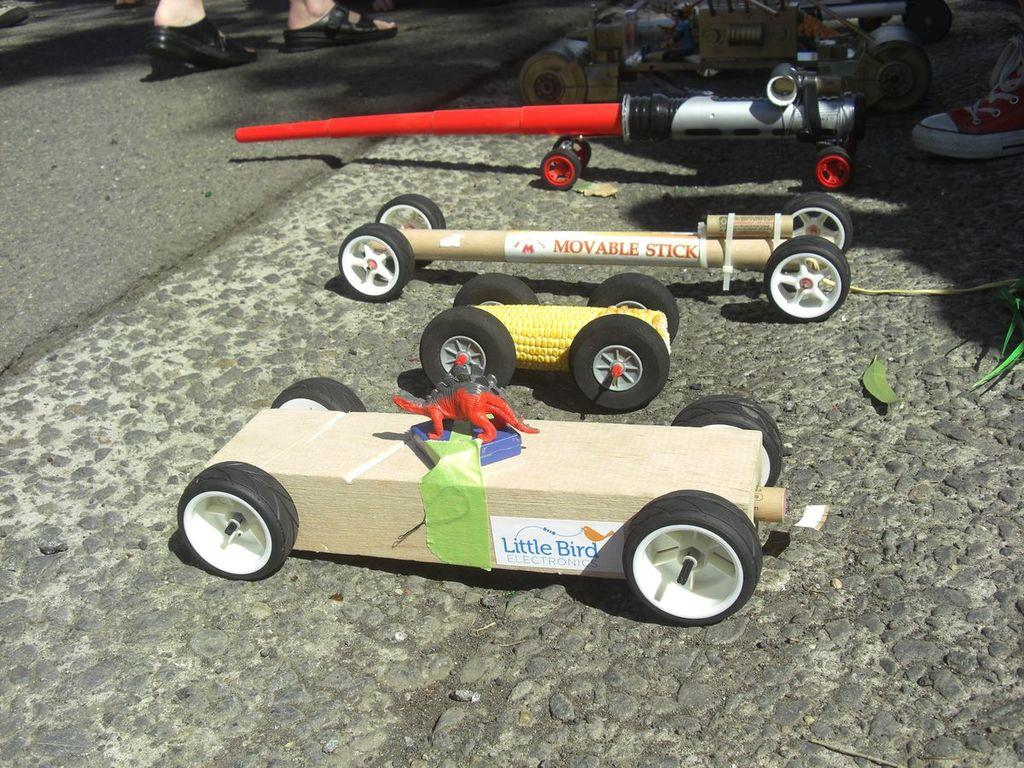What type of man-made vehicles can be seen in the foreground of the image? There are man-made motor vehicles in the foreground of the image. Where are the motor vehicles located? The motor vehicles are on a road. Can you describe any human presence in the image? Yes, there are legs of persons visible on the left and right sides of the image. What type of account is being discussed by the cow in the image? There is no cow present in the image, so no account can be discussed. How many bikes are visible in the image? There are no bikes visible in the image; only motor vehicles are present. 